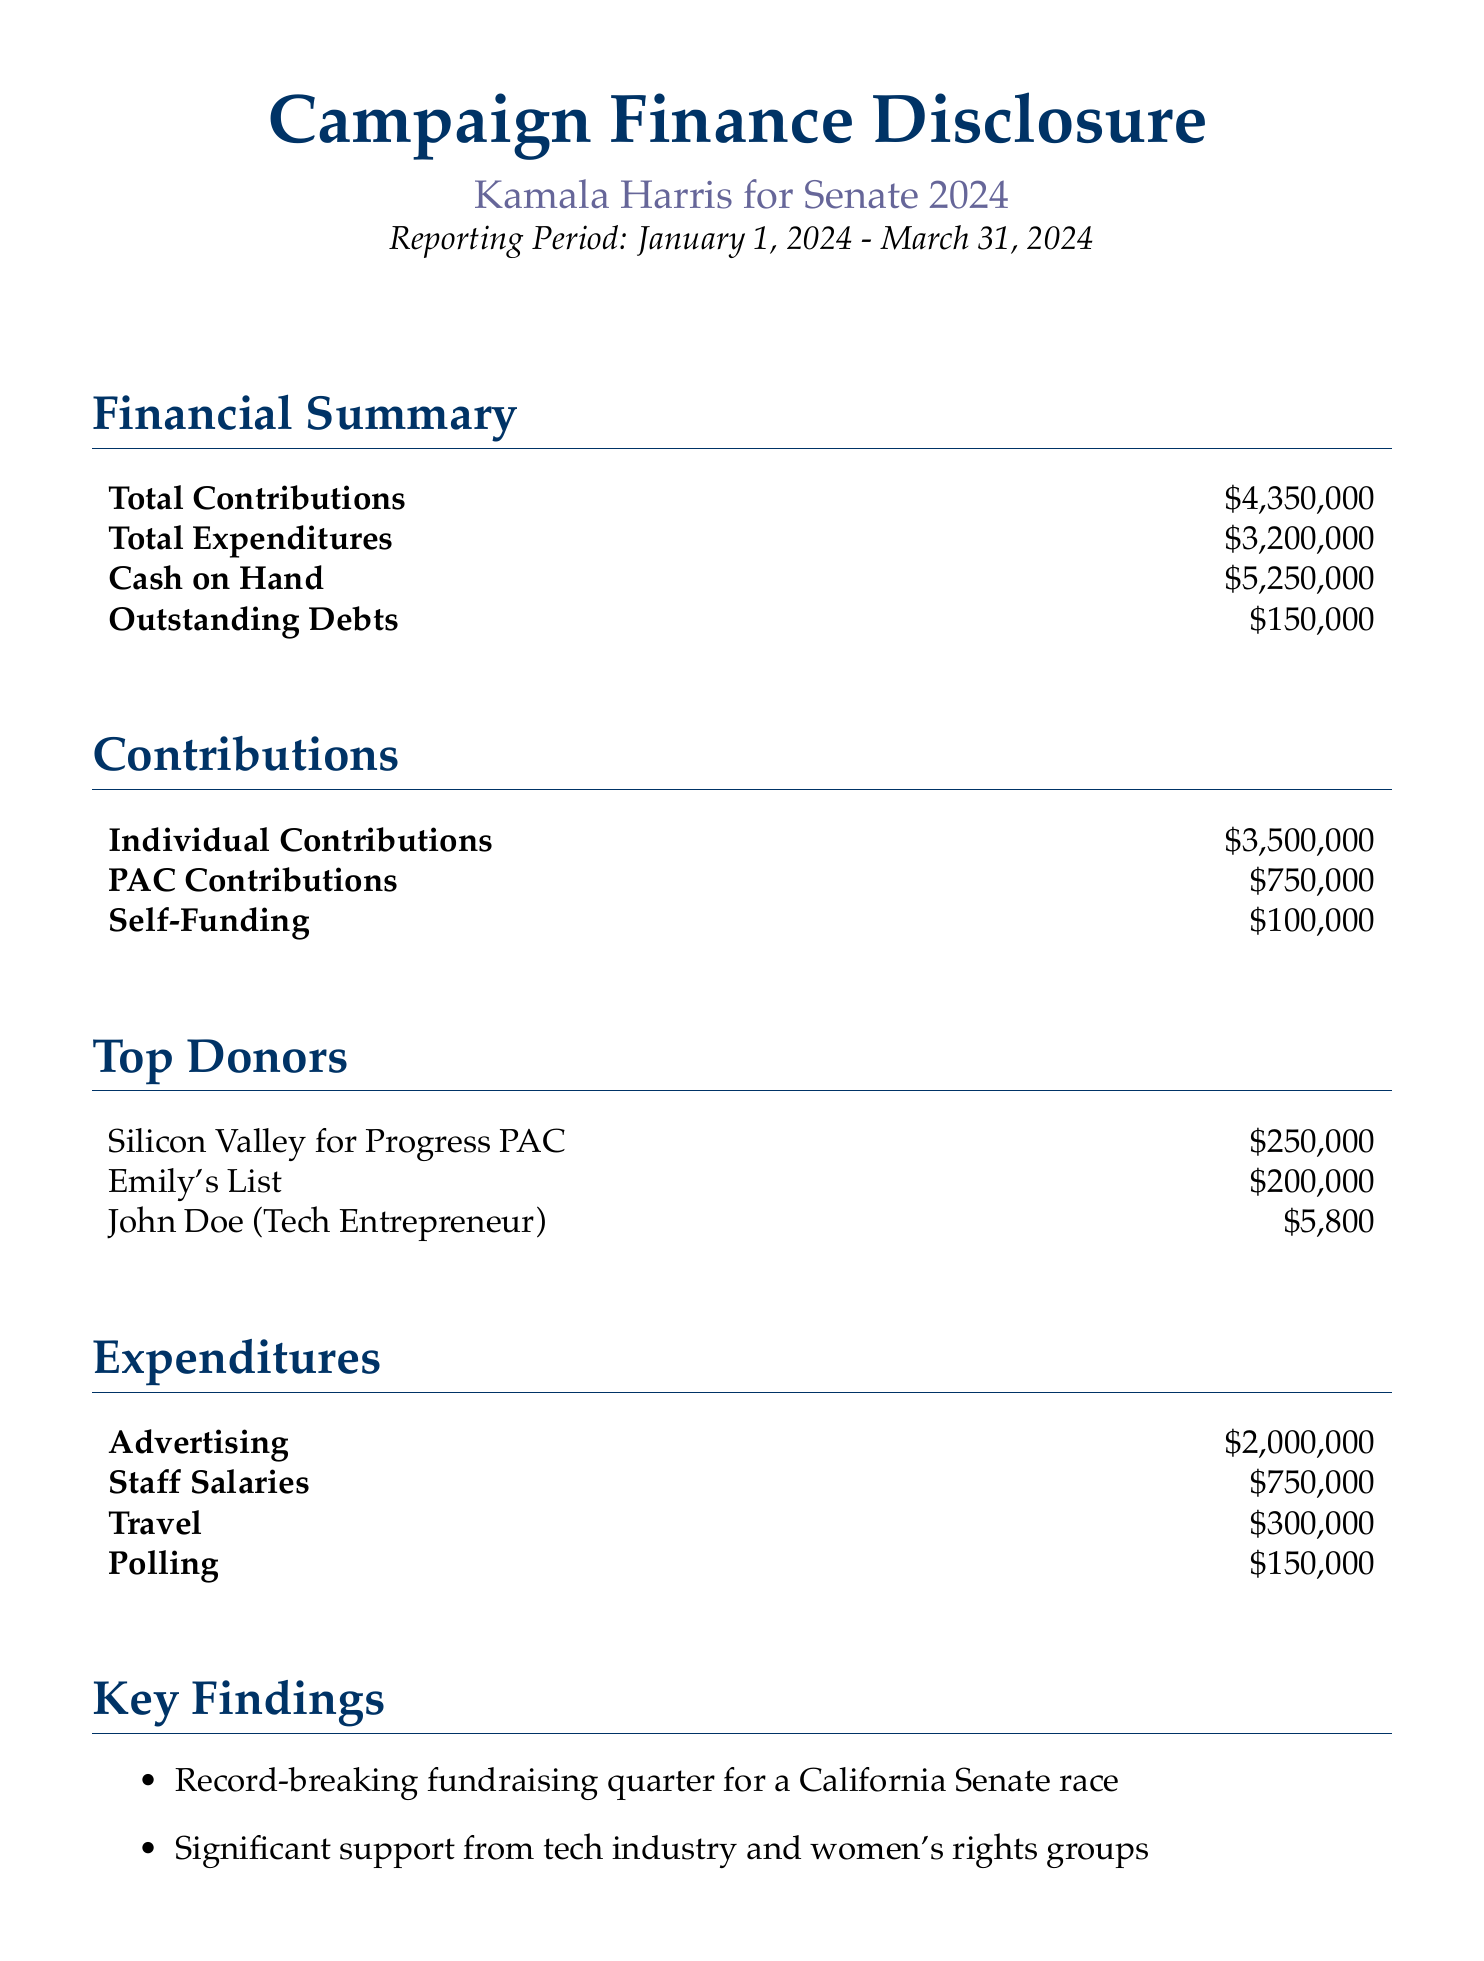What is the total amount of contributions? The total contributions are listed in the financial summary section of the document, totaling $4,350,000.
Answer: $4,350,000 What are the total expenditures? The total expenditures are provided in the financial summary section, amounting to $3,200,000.
Answer: $3,200,000 How much cash is on hand? The cash on hand is mentioned in the financial summary, which states it is $5,250,000.
Answer: $5,250,000 Who is the top donor listed in the document? The section on top donors lists "Silicon Valley for Progress PAC" as the top donor, contributing $250,000.
Answer: Silicon Valley for Progress PAC What is the amount spent on advertising? The expenditures section details that $2,000,000 was spent on advertising.
Answer: $2,000,000 How much was allocated to staff salaries? The financal summary mentions that staff salaries accounted for $750,000 in expenditures.
Answer: $750,000 What significant support is noted in the key findings? The key findings highlight "support from tech industry and women's rights groups."
Answer: Tech industry and women's rights groups What fundraising milestone is noted in the key findings? The key findings indicate it was a "record-breaking fundraising quarter for a California Senate race."
Answer: Record-breaking fundraising quarter What is the period covered in the report? The reporting period stated at the beginning of the document is from January 1, 2024 to March 31, 2024.
Answer: January 1, 2024 - March 31, 2024 